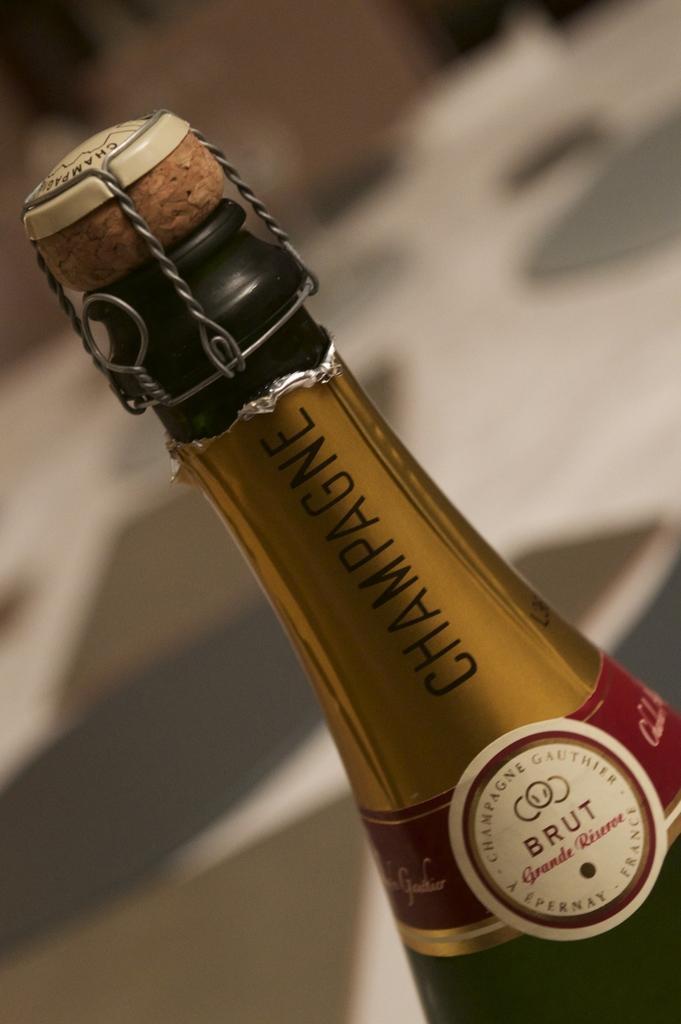Could you give a brief overview of what you see in this image? In this image there is a wine bottle as we can see in middle of this image. 